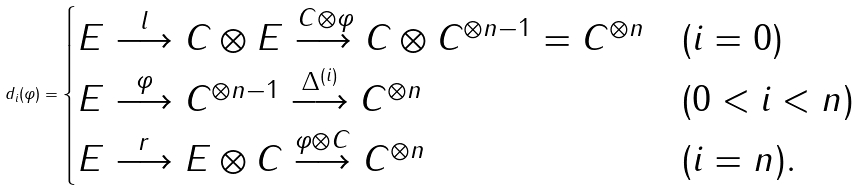Convert formula to latex. <formula><loc_0><loc_0><loc_500><loc_500>d _ { i } ( \varphi ) = \begin{cases} E \stackrel { l } { \longrightarrow } C \otimes E \stackrel { \, C \otimes \varphi } { \longrightarrow } C \otimes C ^ { \otimes n - 1 } = C ^ { \otimes n } & ( i = 0 ) \\ E \stackrel { \varphi } { \longrightarrow } C ^ { \otimes n - 1 } \stackrel { \Delta ^ { ( i ) } } { \longrightarrow } C ^ { \otimes n } & ( 0 < i < n ) \\ E \stackrel { r } { \longrightarrow } E \otimes C \stackrel { \varphi \otimes C } { \longrightarrow } C ^ { \otimes n } & ( i = n ) . \end{cases}</formula> 